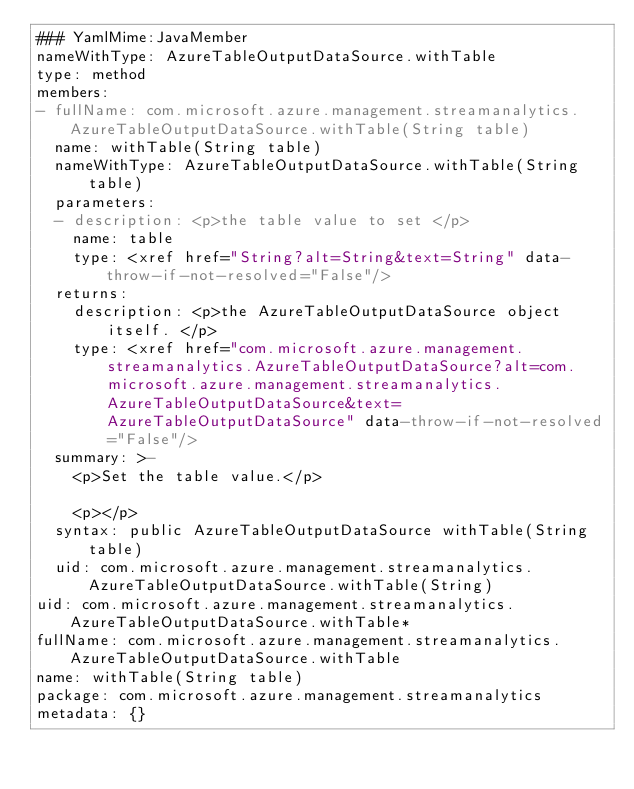<code> <loc_0><loc_0><loc_500><loc_500><_YAML_>### YamlMime:JavaMember
nameWithType: AzureTableOutputDataSource.withTable
type: method
members:
- fullName: com.microsoft.azure.management.streamanalytics.AzureTableOutputDataSource.withTable(String table)
  name: withTable(String table)
  nameWithType: AzureTableOutputDataSource.withTable(String table)
  parameters:
  - description: <p>the table value to set </p>
    name: table
    type: <xref href="String?alt=String&text=String" data-throw-if-not-resolved="False"/>
  returns:
    description: <p>the AzureTableOutputDataSource object itself. </p>
    type: <xref href="com.microsoft.azure.management.streamanalytics.AzureTableOutputDataSource?alt=com.microsoft.azure.management.streamanalytics.AzureTableOutputDataSource&text=AzureTableOutputDataSource" data-throw-if-not-resolved="False"/>
  summary: >-
    <p>Set the table value.</p>

    <p></p>
  syntax: public AzureTableOutputDataSource withTable(String table)
  uid: com.microsoft.azure.management.streamanalytics.AzureTableOutputDataSource.withTable(String)
uid: com.microsoft.azure.management.streamanalytics.AzureTableOutputDataSource.withTable*
fullName: com.microsoft.azure.management.streamanalytics.AzureTableOutputDataSource.withTable
name: withTable(String table)
package: com.microsoft.azure.management.streamanalytics
metadata: {}
</code> 